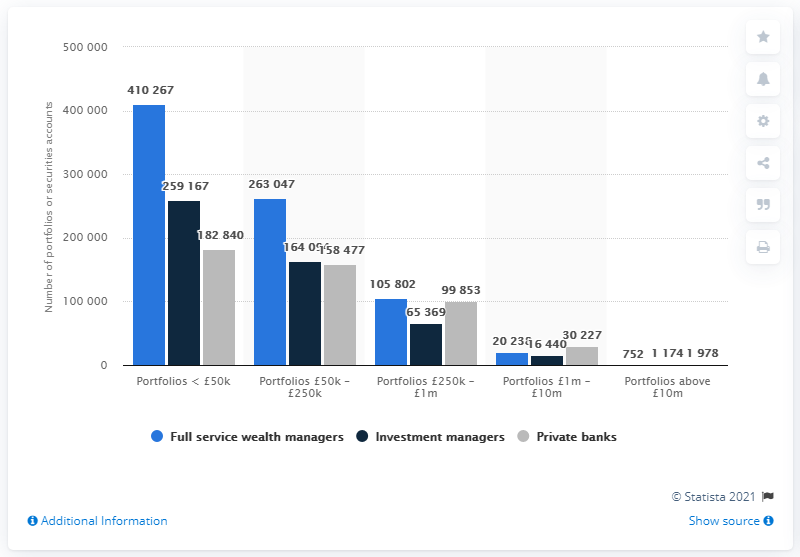List a handful of essential elements in this visual. In 2013, full service wealth managers administered a total of 752 portfolios. 